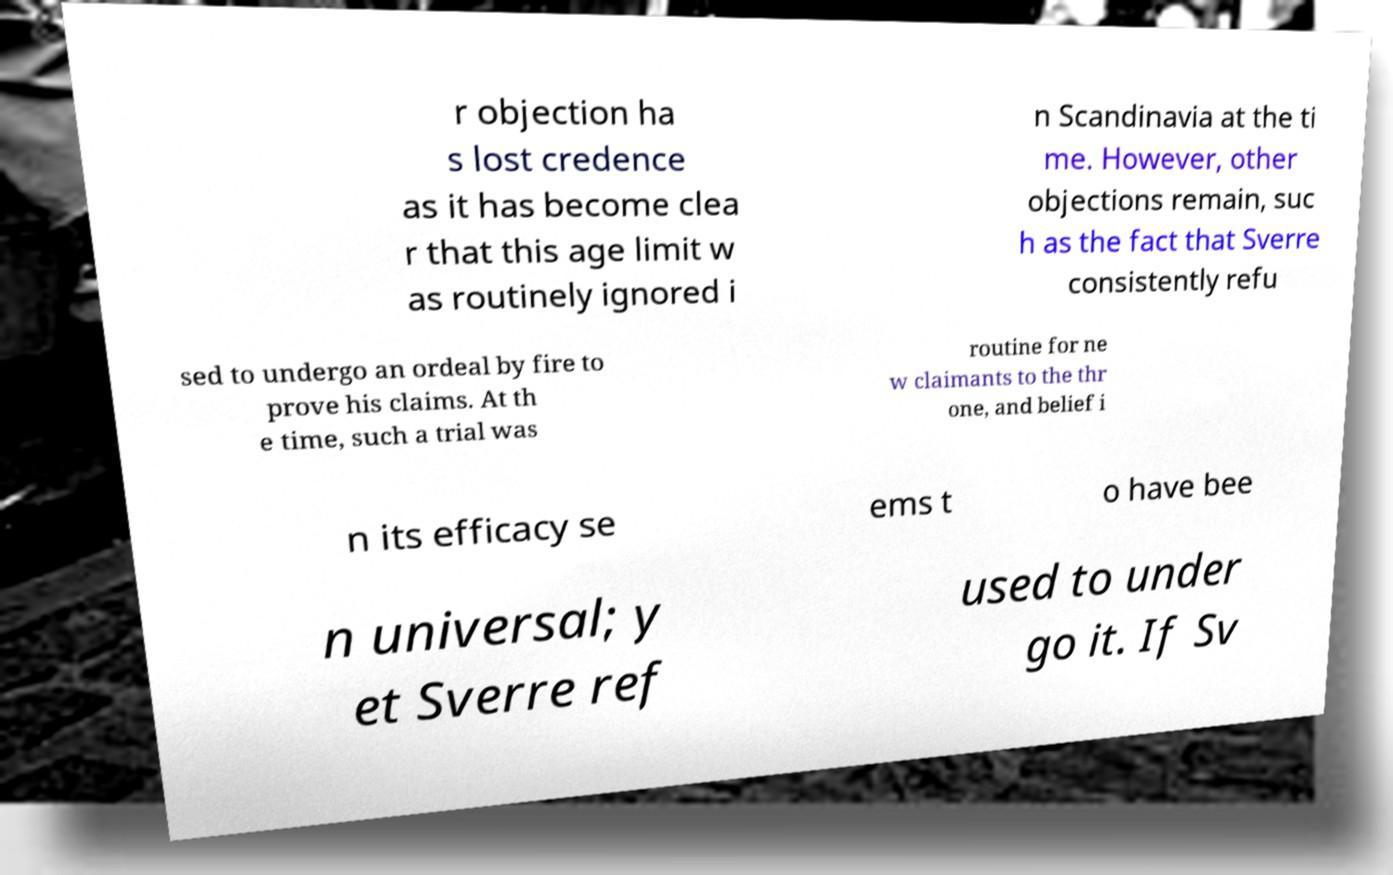I need the written content from this picture converted into text. Can you do that? r objection ha s lost credence as it has become clea r that this age limit w as routinely ignored i n Scandinavia at the ti me. However, other objections remain, suc h as the fact that Sverre consistently refu sed to undergo an ordeal by fire to prove his claims. At th e time, such a trial was routine for ne w claimants to the thr one, and belief i n its efficacy se ems t o have bee n universal; y et Sverre ref used to under go it. If Sv 